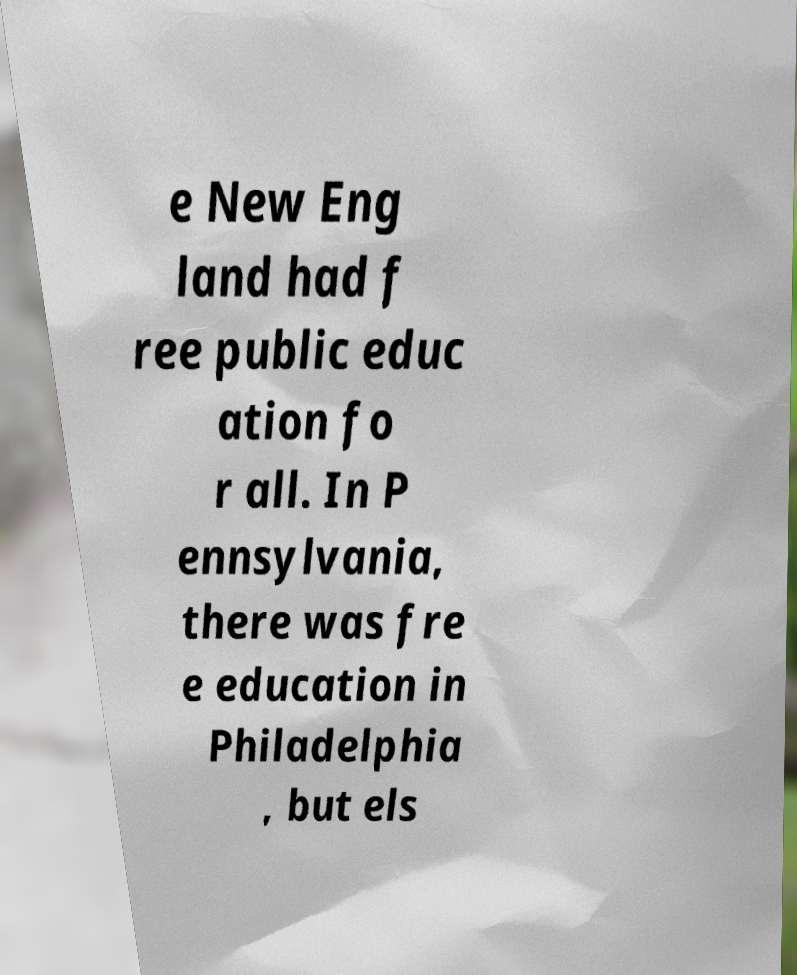Please read and relay the text visible in this image. What does it say? e New Eng land had f ree public educ ation fo r all. In P ennsylvania, there was fre e education in Philadelphia , but els 